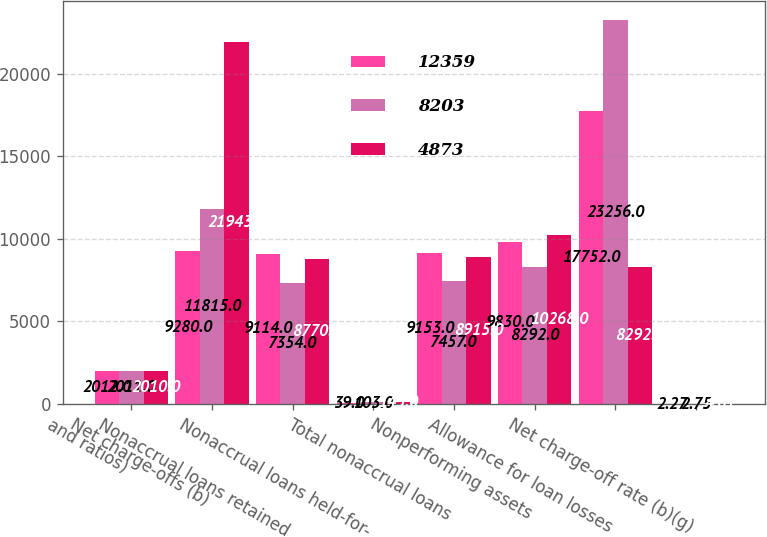Convert chart. <chart><loc_0><loc_0><loc_500><loc_500><stacked_bar_chart><ecel><fcel>and ratios)<fcel>Net charge-offs (b)<fcel>Nonaccrual loans retained<fcel>Nonaccrual loans held-for-<fcel>Total nonaccrual loans<fcel>Nonperforming assets<fcel>Allowance for loan losses<fcel>Net charge-off rate (b)(g)<nl><fcel>12359<fcel>2012<fcel>9280<fcel>9114<fcel>39<fcel>9153<fcel>9830<fcel>17752<fcel>2.27<nl><fcel>8203<fcel>2011<fcel>11815<fcel>7354<fcel>103<fcel>7457<fcel>8292<fcel>23256<fcel>2.75<nl><fcel>4873<fcel>2010<fcel>21943<fcel>8770<fcel>145<fcel>8915<fcel>10268<fcel>8292<fcel>4.61<nl></chart> 